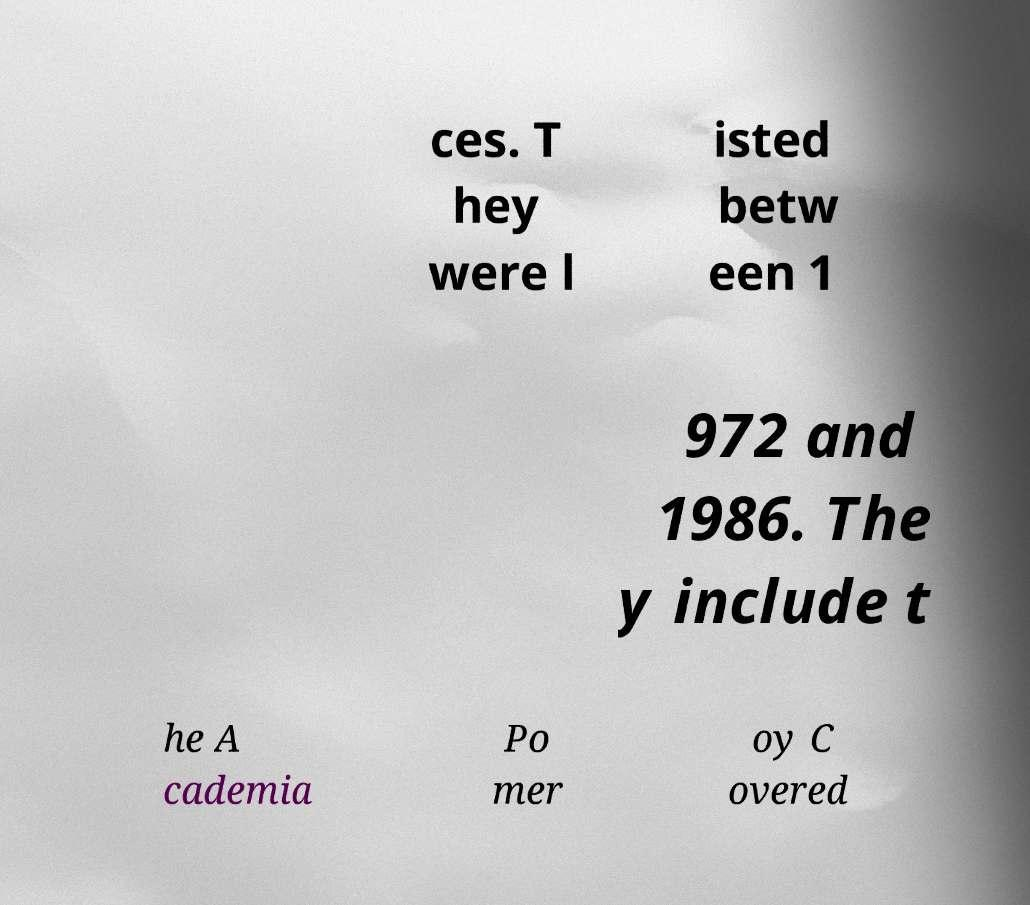Please read and relay the text visible in this image. What does it say? ces. T hey were l isted betw een 1 972 and 1986. The y include t he A cademia Po mer oy C overed 